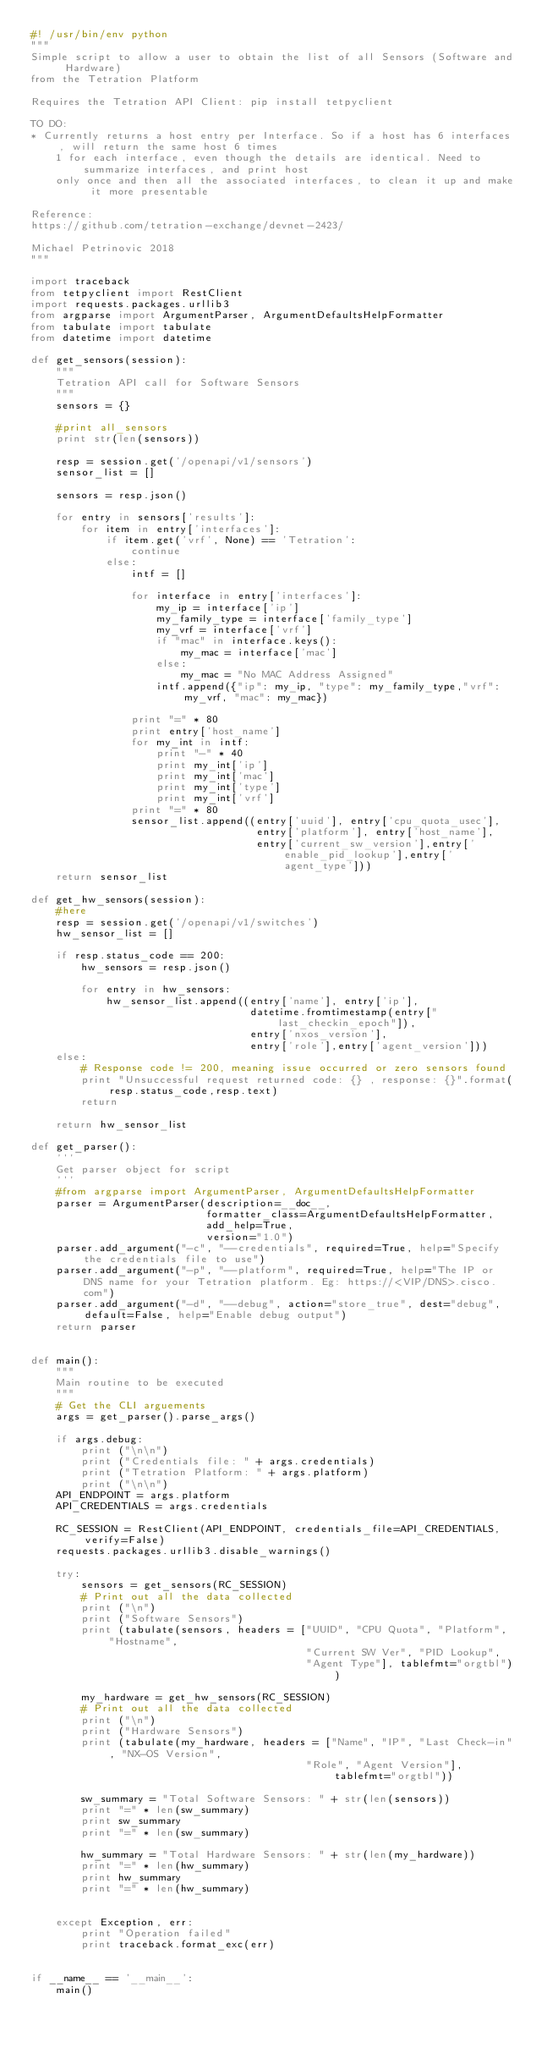Convert code to text. <code><loc_0><loc_0><loc_500><loc_500><_Python_>#! /usr/bin/env python
"""
Simple script to allow a user to obtain the list of all Sensors (Software and Hardware)
from the Tetration Platform

Requires the Tetration API Client: pip install tetpyclient

TO DO:
* Currently returns a host entry per Interface. So if a host has 6 interfaces, will return the same host 6 times
    1 for each interface, even though the details are identical. Need to summarize interfaces, and print host
    only once and then all the associated interfaces, to clean it up and make it more presentable

Reference:
https://github.com/tetration-exchange/devnet-2423/

Michael Petrinovic 2018
"""

import traceback
from tetpyclient import RestClient
import requests.packages.urllib3
from argparse import ArgumentParser, ArgumentDefaultsHelpFormatter
from tabulate import tabulate
from datetime import datetime

def get_sensors(session):
    """
    Tetration API call for Software Sensors
    """
    sensors = {}

    #print all_sensors
    print str(len(sensors))

    resp = session.get('/openapi/v1/sensors')
    sensor_list = []

    sensors = resp.json()

    for entry in sensors['results']:
        for item in entry['interfaces']:
            if item.get('vrf', None) == 'Tetration':
                continue
            else:
                intf = []

                for interface in entry['interfaces']:
                    my_ip = interface['ip']
                    my_family_type = interface['family_type']
                    my_vrf = interface['vrf']
                    if "mac" in interface.keys():
                        my_mac = interface['mac']
                    else:
                        my_mac = "No MAC Address Assigned"
                    intf.append({"ip": my_ip, "type": my_family_type,"vrf": my_vrf, "mac": my_mac})

                print "=" * 80
                print entry['host_name']
                for my_int in intf:
                    print "-" * 40
                    print my_int['ip']
                    print my_int['mac']
                    print my_int['type']
                    print my_int['vrf']
                print "=" * 80
                sensor_list.append((entry['uuid'], entry['cpu_quota_usec'],
                                    entry['platform'], entry['host_name'],
                                    entry['current_sw_version'],entry['enable_pid_lookup'],entry['agent_type']))
    return sensor_list

def get_hw_sensors(session):
    #here
    resp = session.get('/openapi/v1/switches')
    hw_sensor_list = []

    if resp.status_code == 200:
        hw_sensors = resp.json()

        for entry in hw_sensors:
            hw_sensor_list.append((entry['name'], entry['ip'],
                                   datetime.fromtimestamp(entry["last_checkin_epoch"]),
                                   entry['nxos_version'],
                                   entry['role'],entry['agent_version']))
    else:
        # Response code != 200, meaning issue occurred or zero sensors found
        print "Unsuccessful request returned code: {} , response: {}".format(resp.status_code,resp.text)
        return

    return hw_sensor_list

def get_parser():
    '''
    Get parser object for script
    '''
    #from argparse import ArgumentParser, ArgumentDefaultsHelpFormatter
    parser = ArgumentParser(description=__doc__,
                            formatter_class=ArgumentDefaultsHelpFormatter,
                            add_help=True,
                            version="1.0")
    parser.add_argument("-c", "--credentials", required=True, help="Specify the credentials file to use")
    parser.add_argument("-p", "--platform", required=True, help="The IP or DNS name for your Tetration platform. Eg: https://<VIP/DNS>.cisco.com")
    parser.add_argument("-d", "--debug", action="store_true", dest="debug", default=False, help="Enable debug output")
    return parser


def main():
    """
    Main routine to be executed
    """
    # Get the CLI arguements
    args = get_parser().parse_args()

    if args.debug:
        print ("\n\n")
        print ("Credentials file: " + args.credentials)
        print ("Tetration Platform: " + args.platform)
        print ("\n\n")
    API_ENDPOINT = args.platform
    API_CREDENTIALS = args.credentials

    RC_SESSION = RestClient(API_ENDPOINT, credentials_file=API_CREDENTIALS, verify=False)
    requests.packages.urllib3.disable_warnings()

    try:
        sensors = get_sensors(RC_SESSION)
        # Print out all the data collected
        print ("\n")
        print ("Software Sensors")
        print (tabulate(sensors, headers = ["UUID", "CPU Quota", "Platform", "Hostname",
                                            "Current SW Ver", "PID Lookup",
                                            "Agent Type"], tablefmt="orgtbl"))

        my_hardware = get_hw_sensors(RC_SESSION)
        # Print out all the data collected
        print ("\n")
        print ("Hardware Sensors")
        print (tabulate(my_hardware, headers = ["Name", "IP", "Last Check-in", "NX-OS Version",
                                            "Role", "Agent Version"], tablefmt="orgtbl"))

        sw_summary = "Total Software Sensors: " + str(len(sensors))
        print "=" * len(sw_summary)
        print sw_summary
        print "=" * len(sw_summary)

        hw_summary = "Total Hardware Sensors: " + str(len(my_hardware))
        print "=" * len(hw_summary)
        print hw_summary
        print "=" * len(hw_summary)


    except Exception, err:
        print "Operation failed"
        print traceback.format_exc(err)


if __name__ == '__main__':
    main()
</code> 